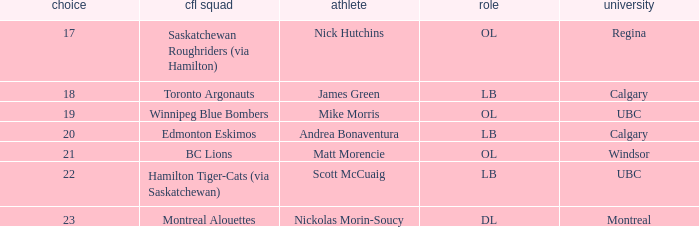Which player is on the BC Lions?  Matt Morencie. 